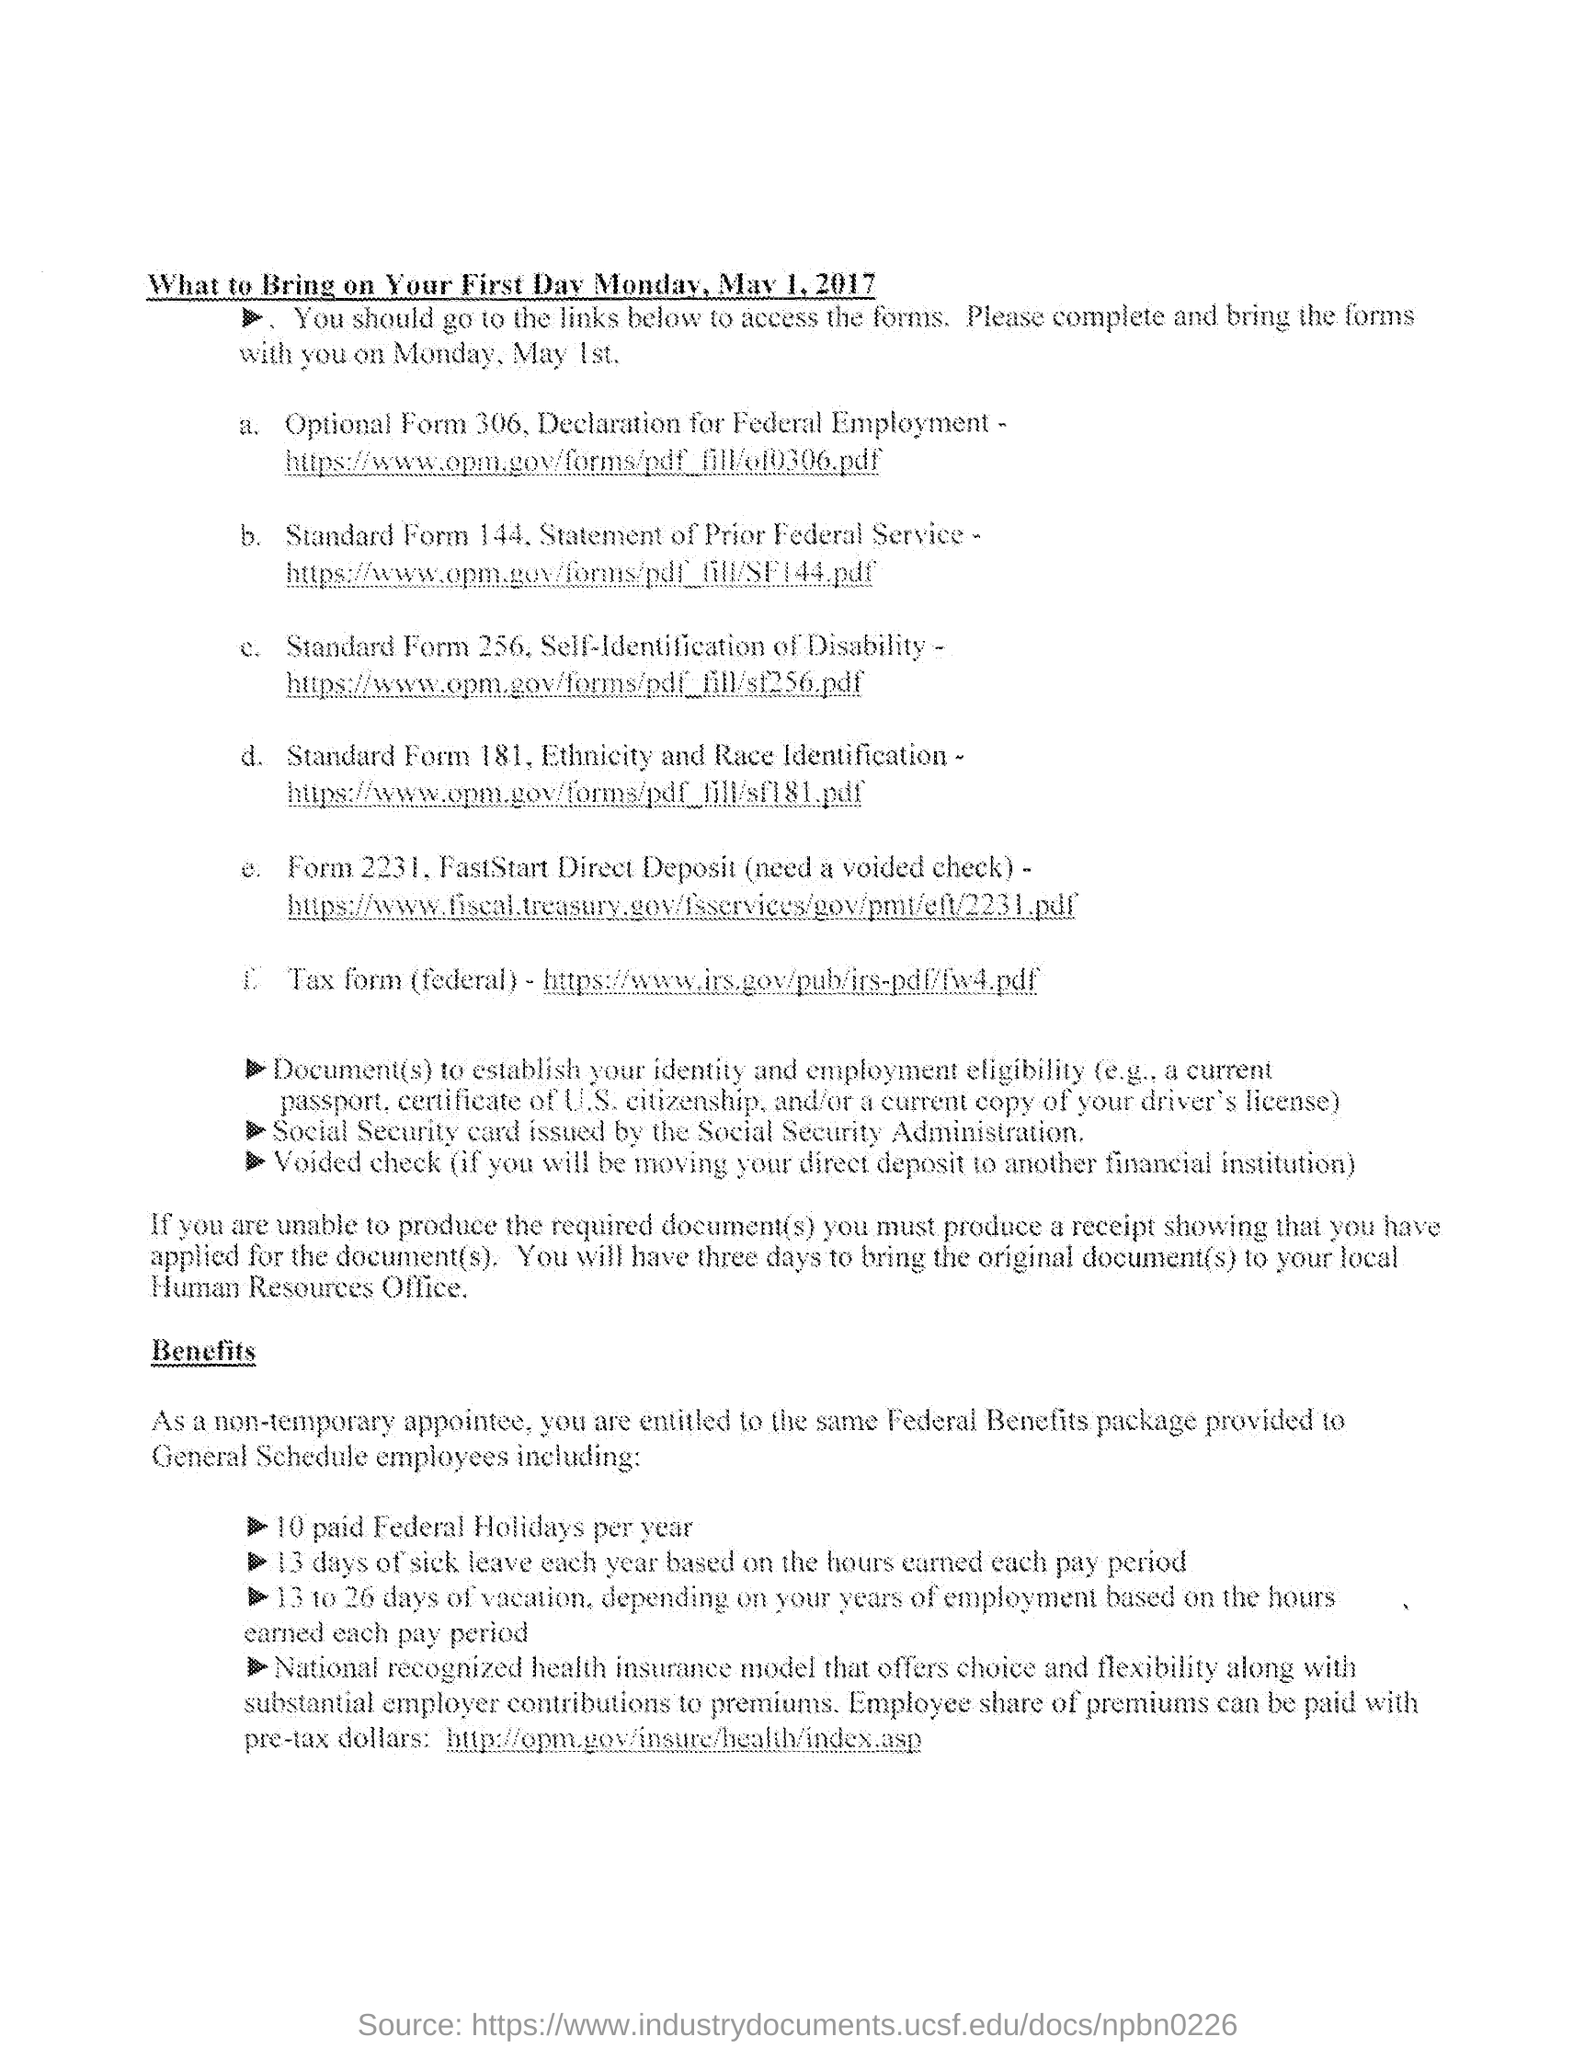Give some essential details in this illustration. On the first day mentioned, which is Monday, May 1, 2017,... In the event that an employee decides to move their direct deposit to another financial institution, they will be required to bring a voided check as proof of their bank account information. 